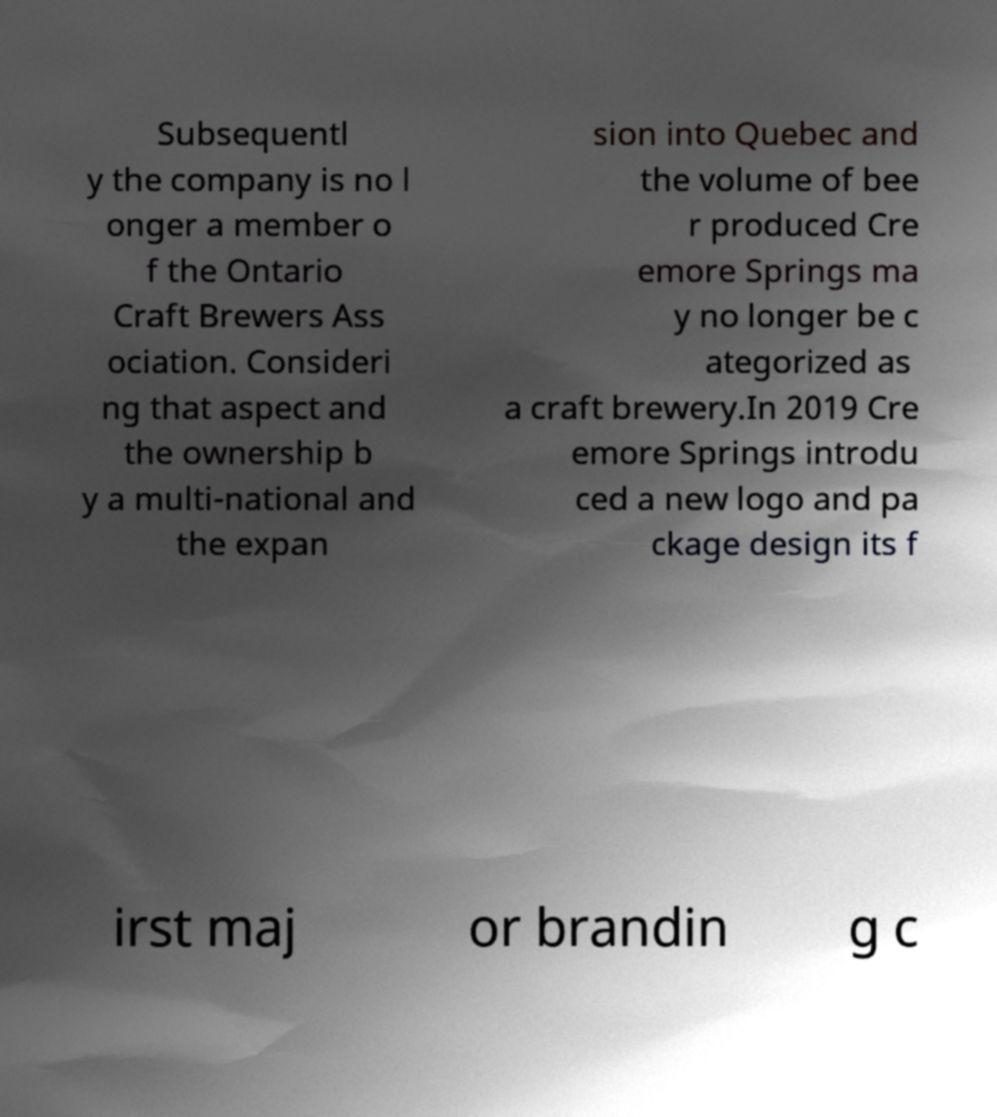What messages or text are displayed in this image? I need them in a readable, typed format. Subsequentl y the company is no l onger a member o f the Ontario Craft Brewers Ass ociation. Consideri ng that aspect and the ownership b y a multi-national and the expan sion into Quebec and the volume of bee r produced Cre emore Springs ma y no longer be c ategorized as a craft brewery.In 2019 Cre emore Springs introdu ced a new logo and pa ckage design its f irst maj or brandin g c 